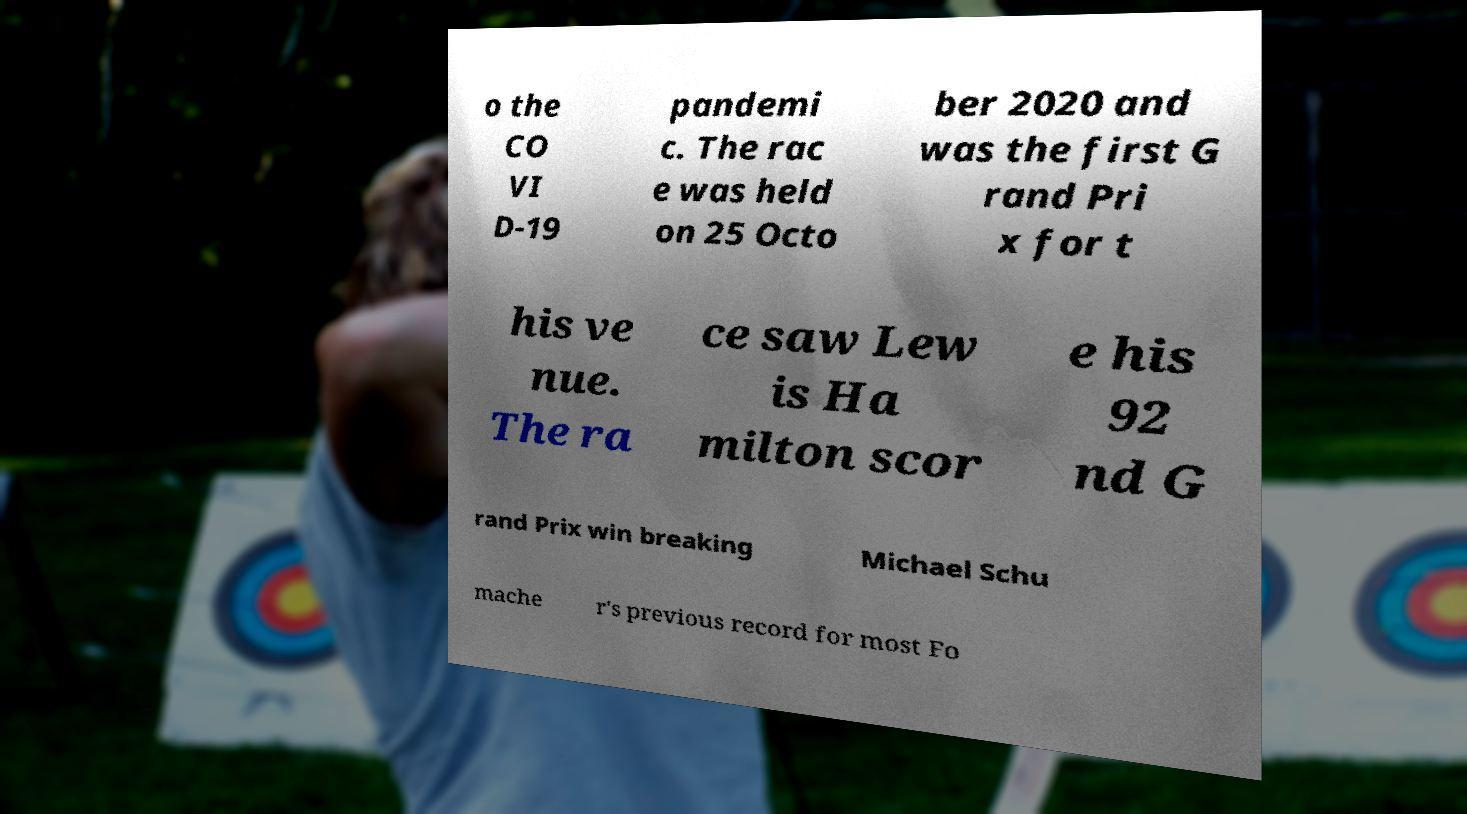Could you extract and type out the text from this image? o the CO VI D-19 pandemi c. The rac e was held on 25 Octo ber 2020 and was the first G rand Pri x for t his ve nue. The ra ce saw Lew is Ha milton scor e his 92 nd G rand Prix win breaking Michael Schu mache r's previous record for most Fo 